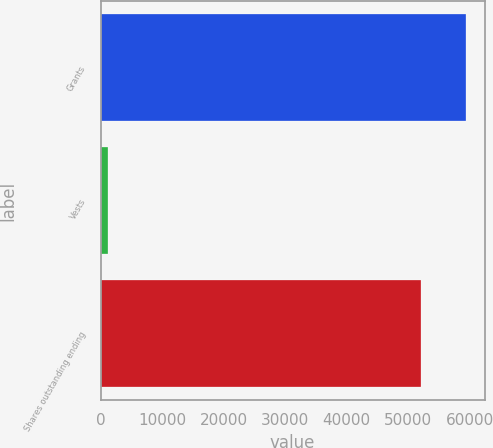Convert chart. <chart><loc_0><loc_0><loc_500><loc_500><bar_chart><fcel>Grants<fcel>Vests<fcel>Shares outstanding ending<nl><fcel>59430<fcel>1262<fcel>51996<nl></chart> 